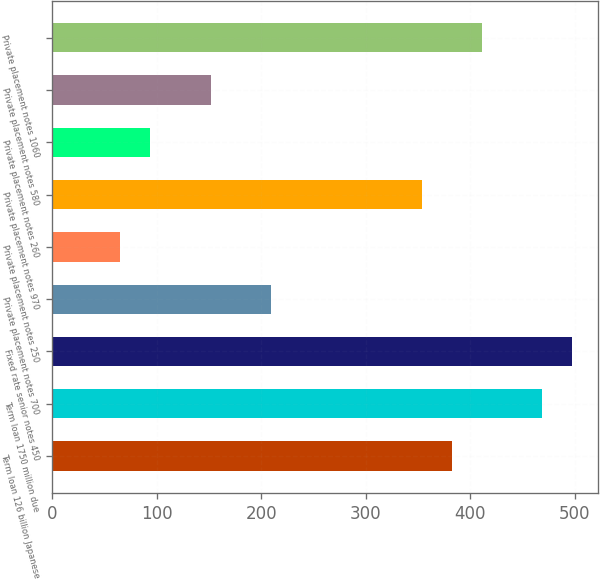Convert chart to OTSL. <chart><loc_0><loc_0><loc_500><loc_500><bar_chart><fcel>Term loan 126 billion Japanese<fcel>Term loan 1750 million due<fcel>Fixed rate senior notes 450<fcel>Private placement notes 700<fcel>Private placement notes 250<fcel>Private placement notes 970<fcel>Private placement notes 260<fcel>Private placement notes 580<fcel>Private placement notes 1060<nl><fcel>382.19<fcel>468.68<fcel>497.51<fcel>209.21<fcel>65.06<fcel>353.36<fcel>93.89<fcel>151.55<fcel>411.02<nl></chart> 